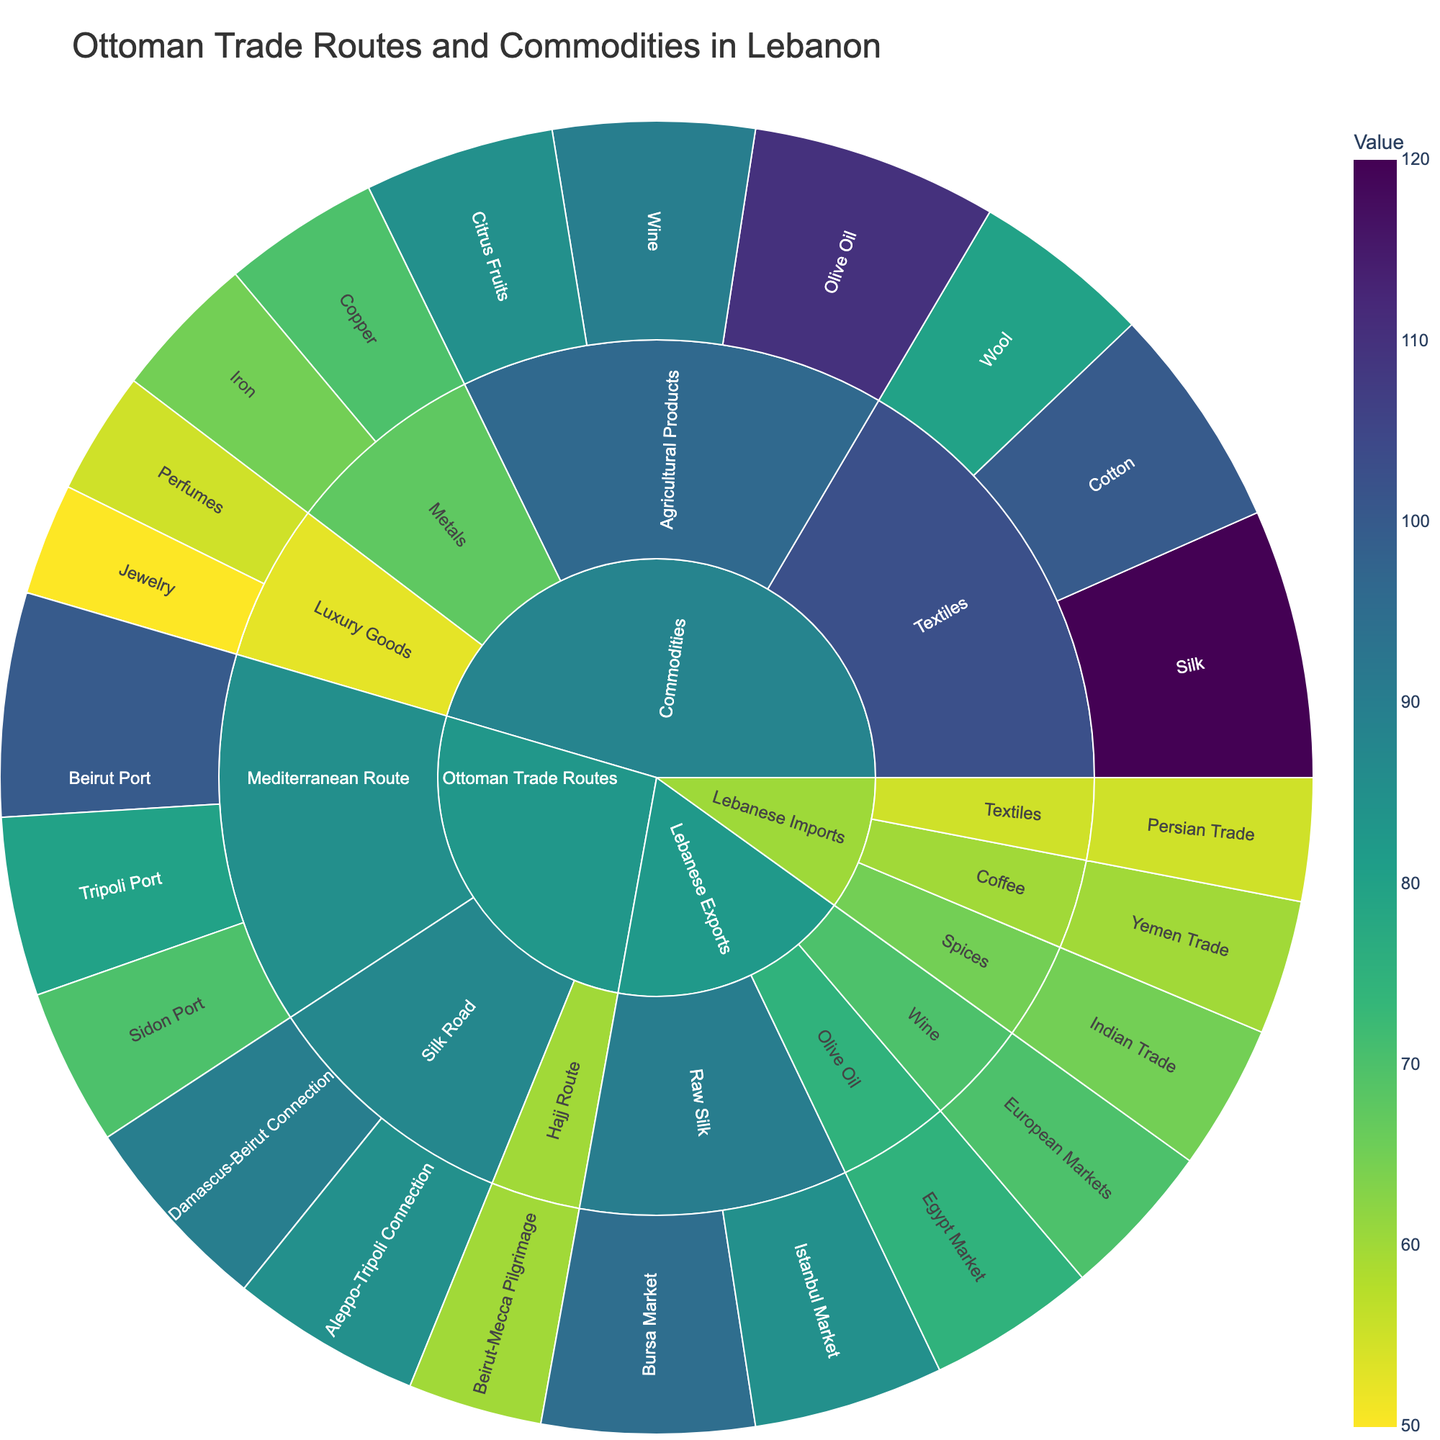What is the title of the Sunburst Plot? The title of the figure is typically displayed at the top of the plot. By looking at the top section of the plot, we can identify it.
Answer: Ottoman Trade Routes and Commodities in Lebanon Which subcategory under 'Lebanese Imports' has the lowest value? By examining the sections under 'Lebanese Imports,' we compare the values of 'Spices,' 'Coffee,' and 'Textiles.' The value of 'Textiles' is the smallest.
Answer: Textiles How does the value of 'Sidon Port' compare to 'Tripoli Port' under 'Mediterranean Route'? First, locate 'Mediterranean Route' under 'Ottoman Trade Routes,' then compare the values of 'Sidon Port' (70) and 'Tripoli Port' (80). 'Sidon Port' has a lower value than 'Tripoli Port.'
Answer: Lower What is the total value of agricultural products under 'Commodities'? Summing up the values of 'Olive Oil' (110), 'Wine' (90), and 'Citrus Fruits' (85) gives us the total value: 110 + 90 + 85 = 285.
Answer: 285 Which category has the highest individual value under 'Lebanese Exports'? By checking each specific value under 'Lebanese Exports,' we see that 'Raw Silk' to 'Bursa Market' has the highest value of 95.
Answer: Raw Silk to Bursa Market What is the difference in value between the 'Beirut-Mecca Pilgrimage' and 'Aleppo-Tripoli Connection'? The value of 'Beirut-Mecca Pilgrimage' is 60 and 'Aleppo-Tripoli Connection' is 85. Subtracting these gives us 85 - 60 = 25.
Answer: 25 Which port under 'Mediterranean Route' has the highest trade value? By comparing the 'Beirut Port,' 'Tripoli Port,' and 'Sidon Port,' we find that 'Beirut Port' has the highest value at 100.
Answer: Beirut Port What is the combined value of textiles under 'Lebanese Imports' and 'Commodities'? The value of 'Textiles' under 'Lebanese Imports' is 55. Summing up 'Silk' (120), 'Cotton' (100), and 'Wool' (80) under 'Commodities' gives us 300. Adding these together: 55 + 300 = 355.
Answer: 355 How does the value of 'Wine' exports to 'European Markets' compare to 'Olive Oil' exports to the 'Egypt Market'? The 'Wine' exports to 'European Markets' is 70, and the 'Olive Oil' to 'Egypt Market' is 75. 'Wine' exports have a lower value.
Answer: Lower Which trade route under 'Ottoman Trade Routes' has the lowest total trade value? By adding up the values of each subcategory under the different trade routes, 'Hajj Route' (60) has the lowest compared to 'Mediterranean Route' (100 + 80 + 70 = 250) and 'Silk Road' (90 + 85 = 175).
Answer: Hajj Route 